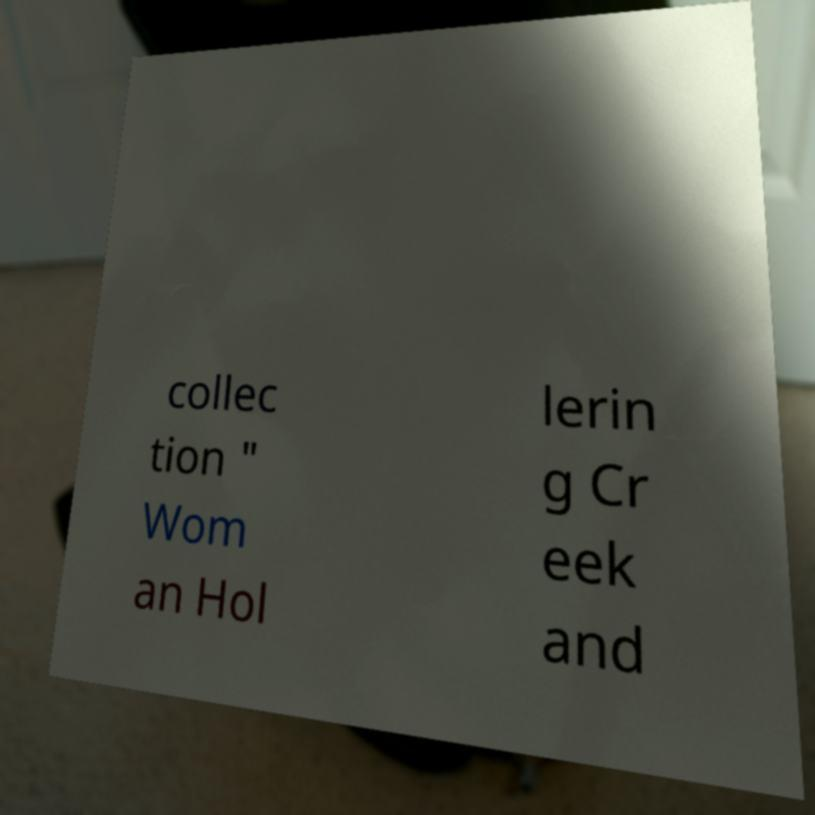Please read and relay the text visible in this image. What does it say? collec tion " Wom an Hol lerin g Cr eek and 